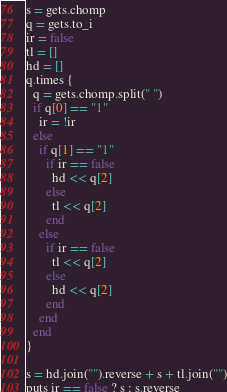Convert code to text. <code><loc_0><loc_0><loc_500><loc_500><_Ruby_>s = gets.chomp
q = gets.to_i
ir = false
tl = []
hd = []
q.times {
  q = gets.chomp.split(" ")
  if q[0] == "1"
    ir = !ir
  else
    if q[1] == "1"
      if ir == false
        hd << q[2]
      else
        tl << q[2]
      end
    else
      if ir == false
        tl << q[2]
      else
        hd << q[2]
      end
    end
  end
}

s = hd.join("").reverse + s + tl.join("")
puts ir == false ? s : s.reverse
</code> 